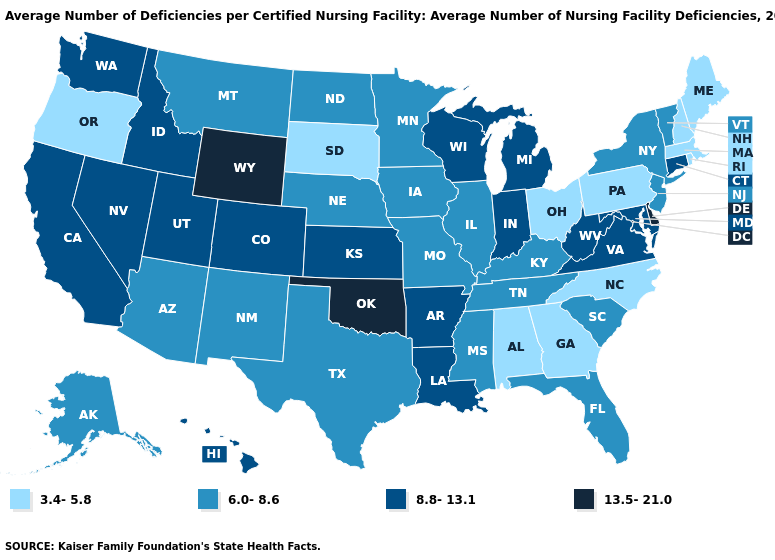Does Louisiana have the same value as Mississippi?
Quick response, please. No. Name the states that have a value in the range 3.4-5.8?
Write a very short answer. Alabama, Georgia, Maine, Massachusetts, New Hampshire, North Carolina, Ohio, Oregon, Pennsylvania, Rhode Island, South Dakota. Does Rhode Island have the lowest value in the Northeast?
Concise answer only. Yes. What is the lowest value in the USA?
Answer briefly. 3.4-5.8. Name the states that have a value in the range 6.0-8.6?
Be succinct. Alaska, Arizona, Florida, Illinois, Iowa, Kentucky, Minnesota, Mississippi, Missouri, Montana, Nebraska, New Jersey, New Mexico, New York, North Dakota, South Carolina, Tennessee, Texas, Vermont. What is the lowest value in states that border Iowa?
Quick response, please. 3.4-5.8. Name the states that have a value in the range 13.5-21.0?
Quick response, please. Delaware, Oklahoma, Wyoming. How many symbols are there in the legend?
Be succinct. 4. Name the states that have a value in the range 13.5-21.0?
Write a very short answer. Delaware, Oklahoma, Wyoming. What is the lowest value in the West?
Quick response, please. 3.4-5.8. What is the value of Rhode Island?
Quick response, please. 3.4-5.8. What is the lowest value in the West?
Give a very brief answer. 3.4-5.8. What is the value of North Carolina?
Be succinct. 3.4-5.8. Name the states that have a value in the range 6.0-8.6?
Keep it brief. Alaska, Arizona, Florida, Illinois, Iowa, Kentucky, Minnesota, Mississippi, Missouri, Montana, Nebraska, New Jersey, New Mexico, New York, North Dakota, South Carolina, Tennessee, Texas, Vermont. What is the value of Missouri?
Write a very short answer. 6.0-8.6. 